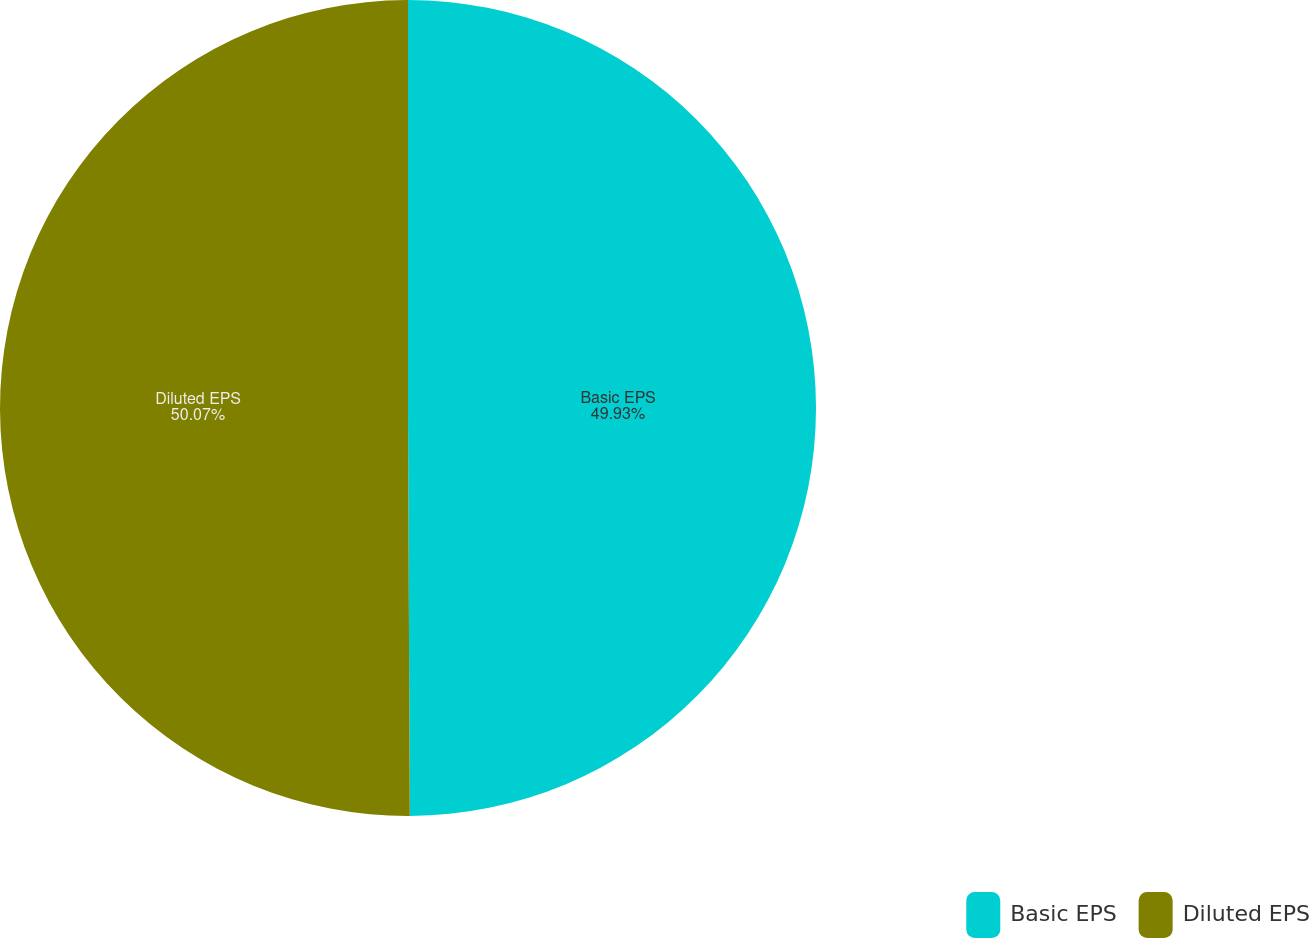Convert chart to OTSL. <chart><loc_0><loc_0><loc_500><loc_500><pie_chart><fcel>Basic EPS<fcel>Diluted EPS<nl><fcel>49.93%<fcel>50.07%<nl></chart> 